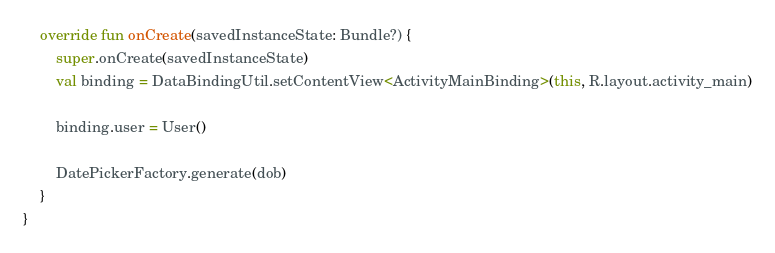Convert code to text. <code><loc_0><loc_0><loc_500><loc_500><_Kotlin_>    override fun onCreate(savedInstanceState: Bundle?) {
        super.onCreate(savedInstanceState)
        val binding = DataBindingUtil.setContentView<ActivityMainBinding>(this, R.layout.activity_main)

        binding.user = User()

        DatePickerFactory.generate(dob)
    }
}
</code> 